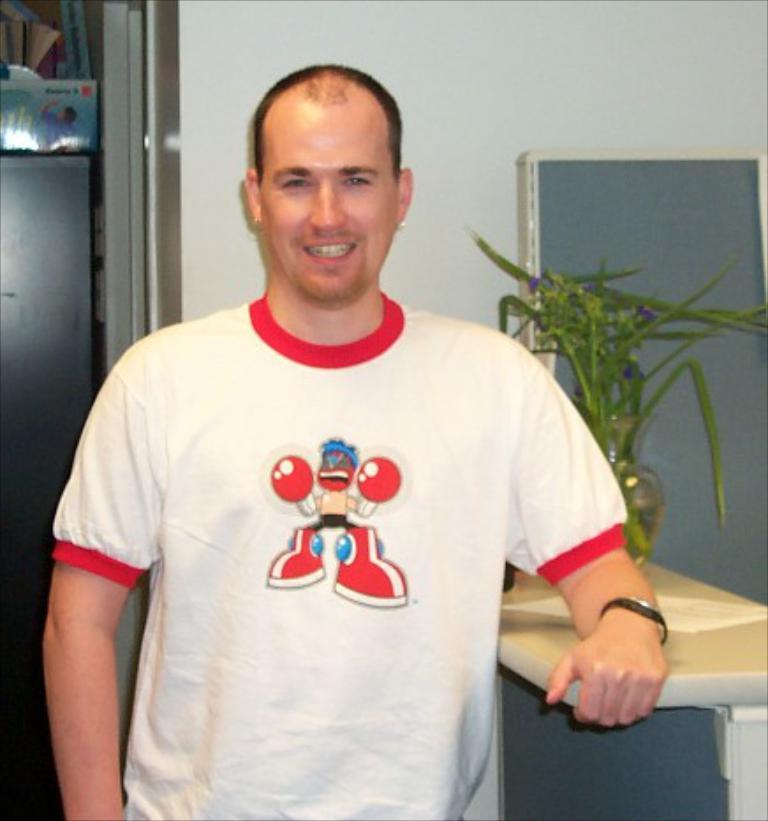How would you summarize this image in a sentence or two? In this picture we can see a person, he is smiling and in the background we can see a wall, pot with a plant and some objects. 